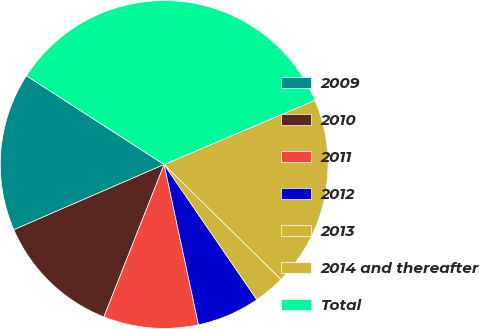Convert chart to OTSL. <chart><loc_0><loc_0><loc_500><loc_500><pie_chart><fcel>2009<fcel>2010<fcel>2011<fcel>2012<fcel>2013<fcel>2014 and thereafter<fcel>Total<nl><fcel>15.63%<fcel>12.49%<fcel>9.35%<fcel>6.21%<fcel>3.07%<fcel>18.77%<fcel>34.47%<nl></chart> 